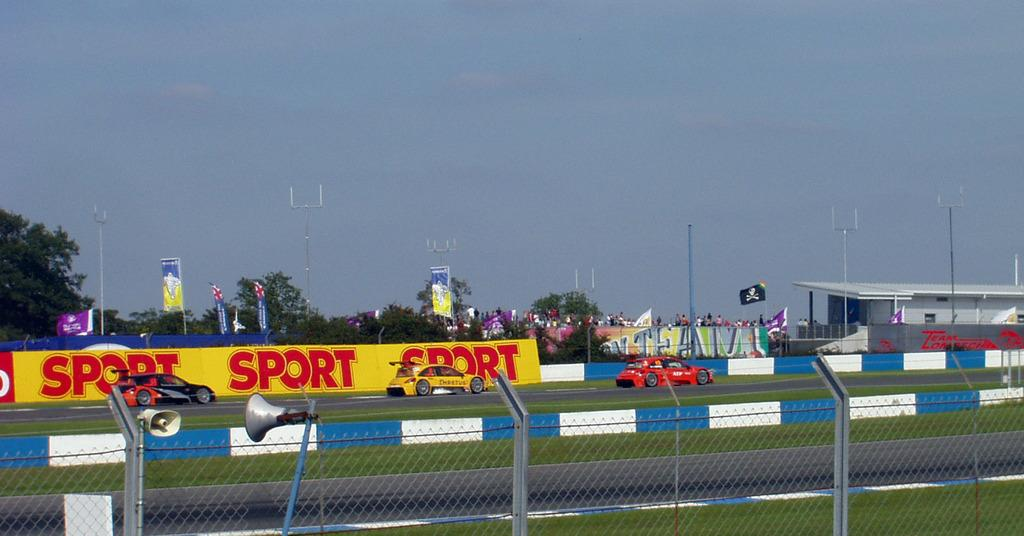<image>
Create a compact narrative representing the image presented. Race track with a banner that says "SPORT" on the side. 